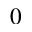<formula> <loc_0><loc_0><loc_500><loc_500>_ { 0 }</formula> 